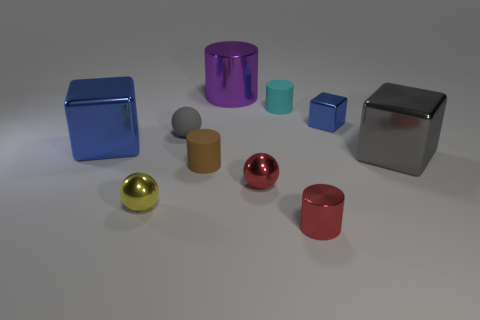Subtract 1 cylinders. How many cylinders are left? 3 Subtract all purple blocks. How many gray balls are left? 1 Subtract all large cyan metallic cylinders. Subtract all yellow things. How many objects are left? 9 Add 4 cylinders. How many cylinders are left? 8 Add 8 gray things. How many gray things exist? 10 Subtract all red spheres. How many spheres are left? 2 Subtract all tiny metallic spheres. How many spheres are left? 1 Subtract 0 yellow blocks. How many objects are left? 10 Subtract all blocks. How many objects are left? 7 Subtract all green blocks. Subtract all purple cylinders. How many blocks are left? 3 